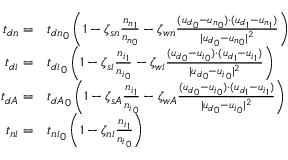<formula> <loc_0><loc_0><loc_500><loc_500>\begin{array} { r l } { { t _ { d n } } = } & { t _ { d n } } _ { 0 } \left ( 1 - \zeta _ { s n } \frac { { n _ { n } } _ { 1 } } { { n _ { n } } _ { 0 } } - \zeta _ { w n } \frac { ( { u _ { d } } _ { 0 } - { u _ { n } } _ { 0 } ) \cdot ( { u _ { d } } _ { 1 } - { u _ { n } } _ { 1 } ) } { | { u _ { d } } _ { 0 } - { u _ { n } } _ { 0 } | ^ { 2 } } \right ) } \\ { { t _ { d i } } = } & { t _ { d i } } _ { 0 } \left ( 1 - \zeta _ { s i } \frac { { n _ { i } } _ { 1 } } { { n _ { i } } _ { 0 } } - \zeta _ { w i } \frac { ( { u _ { d } } _ { 0 } - { u _ { i } } _ { 0 } ) \cdot ( { u _ { d } } _ { 1 } - { u _ { i } } _ { 1 } ) } { | { u _ { d } } _ { 0 } - { u _ { i } } _ { 0 } | ^ { 2 } } \right ) } \\ { { t _ { d A } } = } & { t _ { d A } } _ { 0 } \left ( 1 - \zeta _ { s A } \frac { { n _ { i } } _ { 1 } } { { n _ { i } } _ { 0 } } - \zeta _ { w A } \frac { ( { u _ { d } } _ { 0 } - { u _ { i } } _ { 0 } ) \cdot ( { u _ { d } } _ { 1 } - { u _ { i } } _ { 1 } ) } { | { u _ { d } } _ { 0 } - { u _ { i } } _ { 0 } | ^ { 2 } } \right ) } \\ { { t _ { n i } } = } & { t _ { n i } } _ { 0 } \left ( 1 - \zeta _ { n i } \frac { { n _ { i } } _ { 1 } } { { n _ { i } } _ { 0 } } \right ) } \end{array}</formula> 